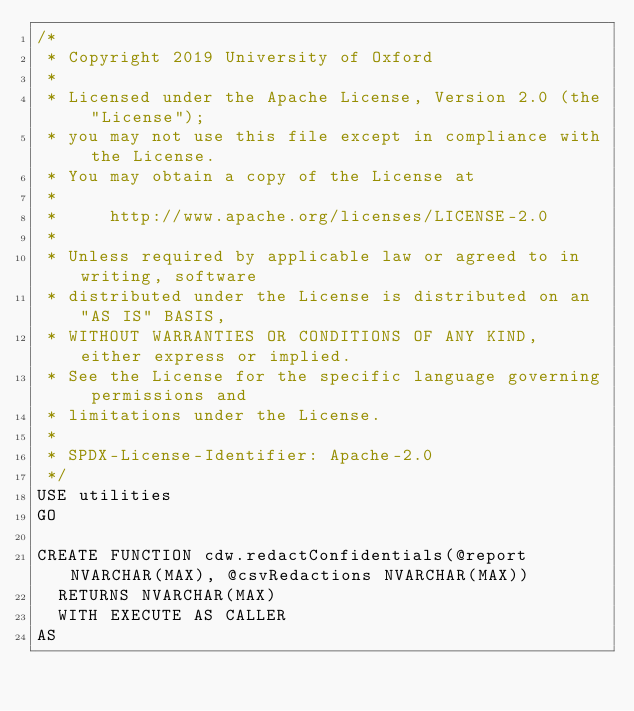<code> <loc_0><loc_0><loc_500><loc_500><_SQL_>/*
 * Copyright 2019 University of Oxford
 *
 * Licensed under the Apache License, Version 2.0 (the "License");
 * you may not use this file except in compliance with the License.
 * You may obtain a copy of the License at
 *
 *     http://www.apache.org/licenses/LICENSE-2.0
 *
 * Unless required by applicable law or agreed to in writing, software
 * distributed under the License is distributed on an "AS IS" BASIS,
 * WITHOUT WARRANTIES OR CONDITIONS OF ANY KIND, either express or implied.
 * See the License for the specific language governing permissions and
 * limitations under the License.
 *
 * SPDX-License-Identifier: Apache-2.0
 */
USE utilities
GO

CREATE FUNCTION cdw.redactConfidentials(@report NVARCHAR(MAX), @csvRedactions NVARCHAR(MAX))
  RETURNS NVARCHAR(MAX)
  WITH EXECUTE AS CALLER
AS</code> 